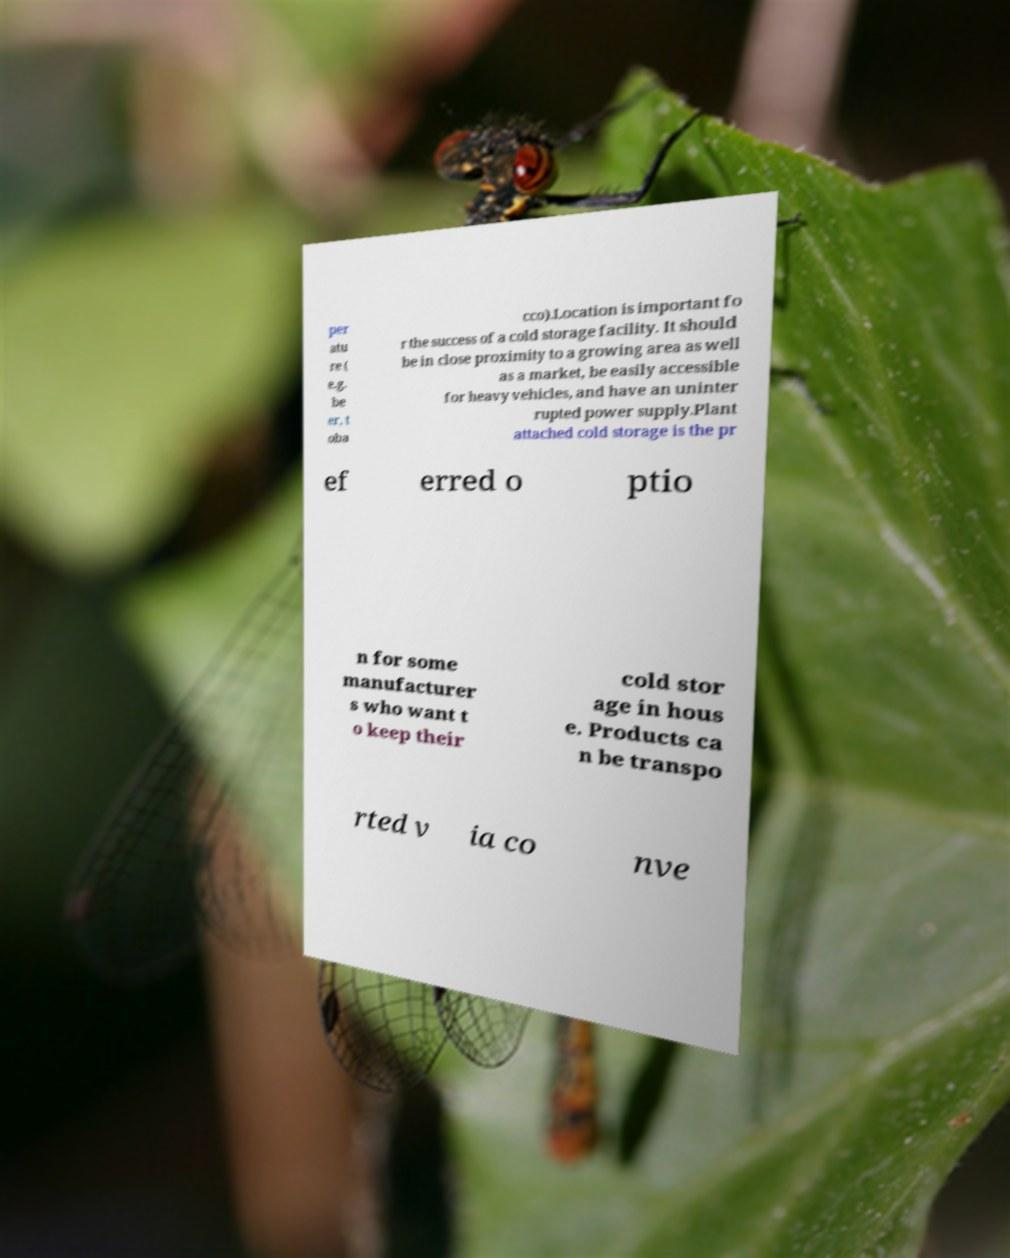What messages or text are displayed in this image? I need them in a readable, typed format. per atu re ( e.g. be er, t oba cco).Location is important fo r the success of a cold storage facility. It should be in close proximity to a growing area as well as a market, be easily accessible for heavy vehicles, and have an uninter rupted power supply.Plant attached cold storage is the pr ef erred o ptio n for some manufacturer s who want t o keep their cold stor age in hous e. Products ca n be transpo rted v ia co nve 